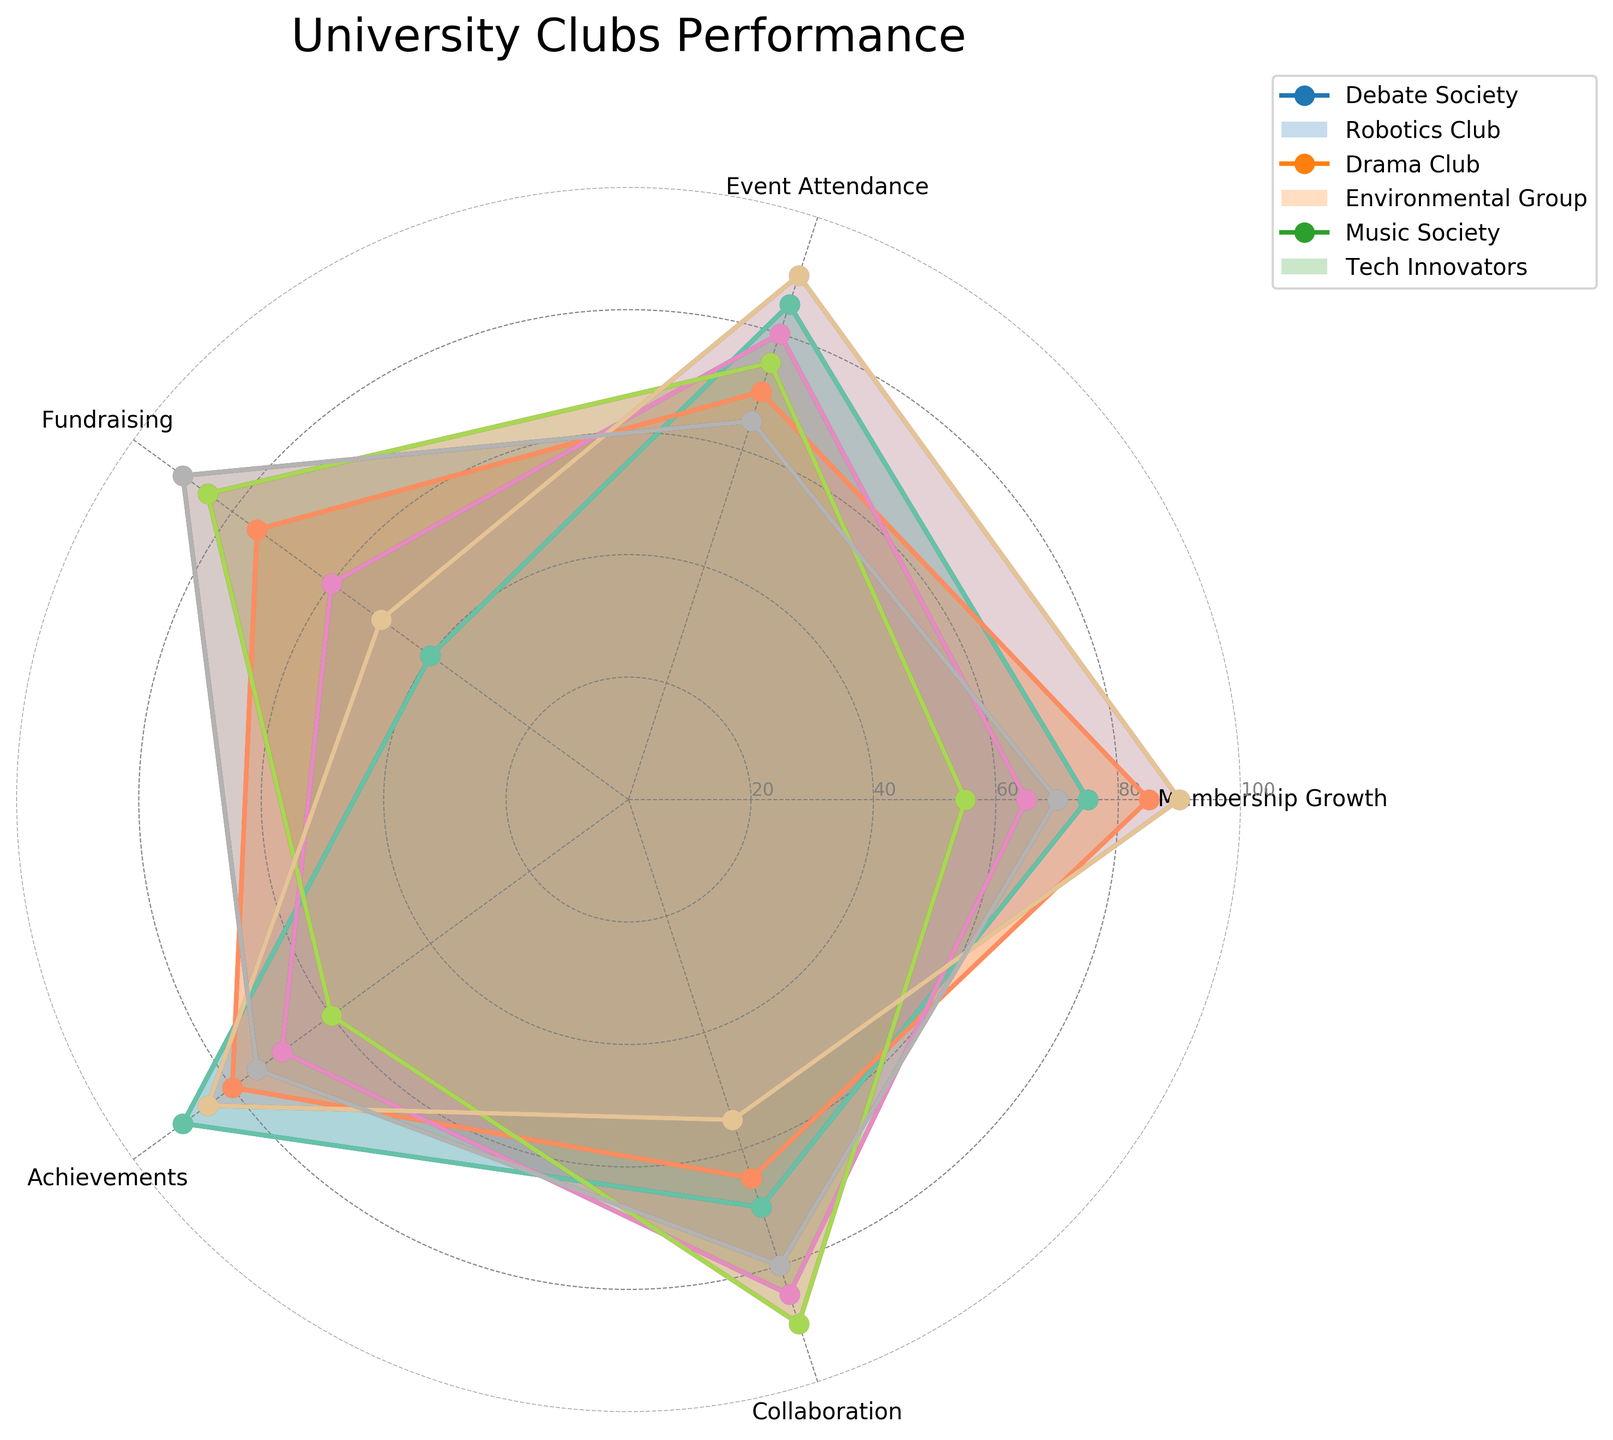What's the title of the figure? The title is written prominently at the top of the figure. It should be observed directly from the chart.
Answer: University Clubs Performance How many categories are evaluated for each club? By looking at the number of labeled axes extending from the center of the radar chart, we count the categories.
Answer: 5 Which club has the highest membership growth? The angle corresponding to "Membership Growth" reflects the values for each club. The club with the longest line in this direction has the highest value.
Answer: Music Society Which club has the lowest fundraising score? The angle corresponding to "Fundraising" indicates the values for each club. The club with the shortest distance from the center in this direction has the lowest score.
Answer: Debate Society What is the combined performance score of the Drama Club in Event Attendance and Achievements? Identify the values for the Drama Club in "Event Attendance" and "Achievements", then sum them up (80 + 70).
Answer: 150 Which two clubs have the most similar performance patterns across all categories? By comparing each club's polygon shape and size, it can be observed which two overlap and align most closely.
Answer: Debate Society and Tech Innovators On average, which club rates the highest across all categories? Calculate the average score for each club by summing their scores across all categories and dividing by the number of categories. Compare these averages.
Answer: Music Society In terms of collaboration, which club stands out the most? Find the angle for "Collaboration" and observe which club reaches the farthest outwards.
Answer: Environmental Group Which category has the most evenly distributed scores among all clubs? Observe the spread (or range) of values for each category. The category showing the smallest spread has the most evenly distributed scores.
Answer: Achievements 